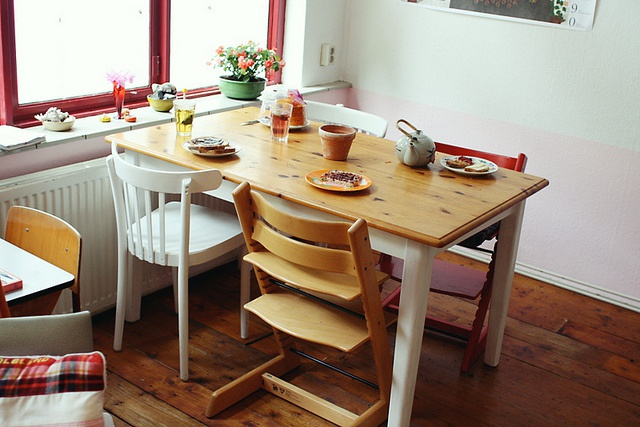Describe the objects in this image and their specific colors. I can see dining table in brown, tan, beige, and maroon tones, chair in brown, maroon, black, and tan tones, chair in brown, lightgray, darkgray, gray, and maroon tones, chair in brown, gray, lightgray, maroon, and darkgray tones, and chair in brown, orange, red, and tan tones in this image. 